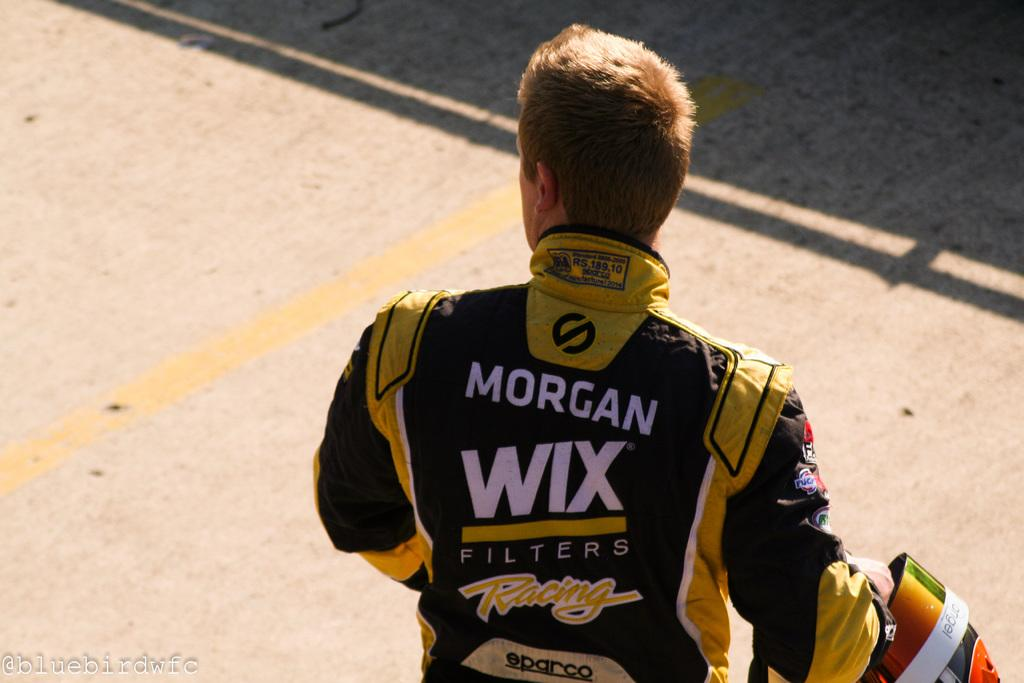<image>
Write a terse but informative summary of the picture. A man in racing gear advertising Wix filters. 